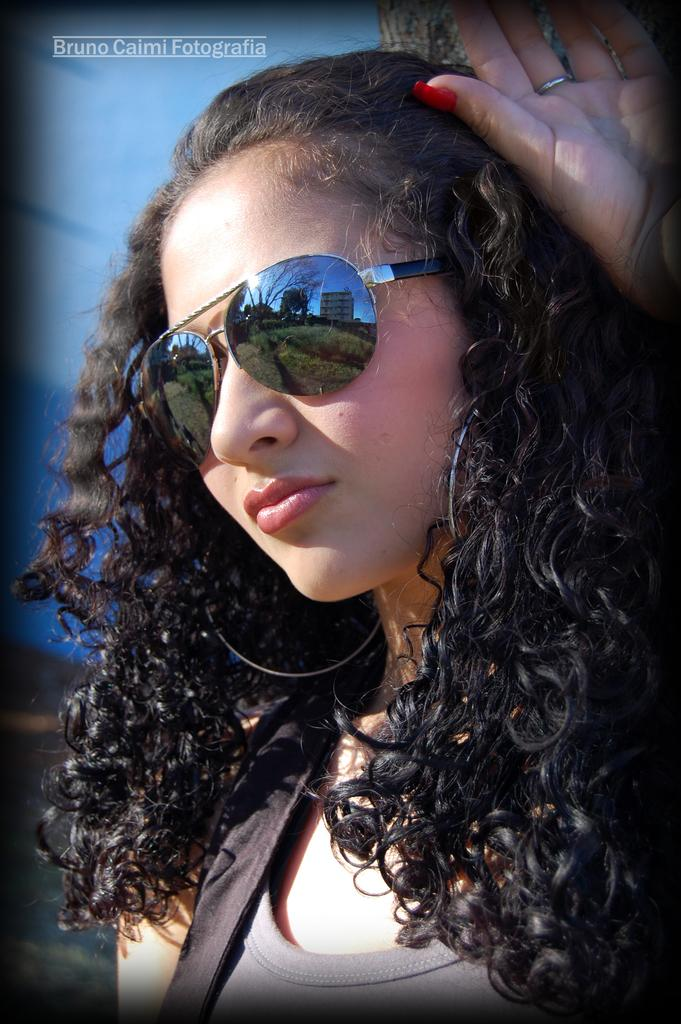Who is present in the image? There is a woman in the image. What accessory is the woman wearing? The woman is wearing spectacles. Where can text be found in the image? Text is visible in the top left side of the image. What is the woman thinking about in the image? There is no indication of the woman's thoughts in the image, so it cannot be determined from the picture. 